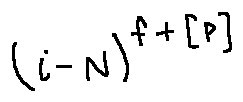<formula> <loc_0><loc_0><loc_500><loc_500>( i - N ) ^ { f + [ P ] }</formula> 